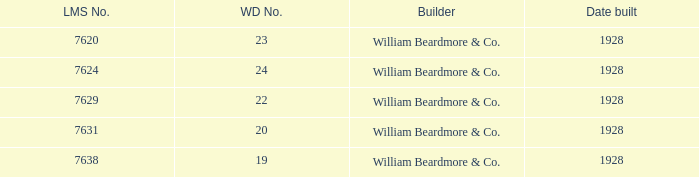Identify the overall quantity of wd figure for lms digit amounting to 763 1.0. Help me parse the entirety of this table. {'header': ['LMS No.', 'WD No.', 'Builder', 'Date built'], 'rows': [['7620', '23', 'William Beardmore & Co.', '1928'], ['7624', '24', 'William Beardmore & Co.', '1928'], ['7629', '22', 'William Beardmore & Co.', '1928'], ['7631', '20', 'William Beardmore & Co.', '1928'], ['7638', '19', 'William Beardmore & Co.', '1928']]} 